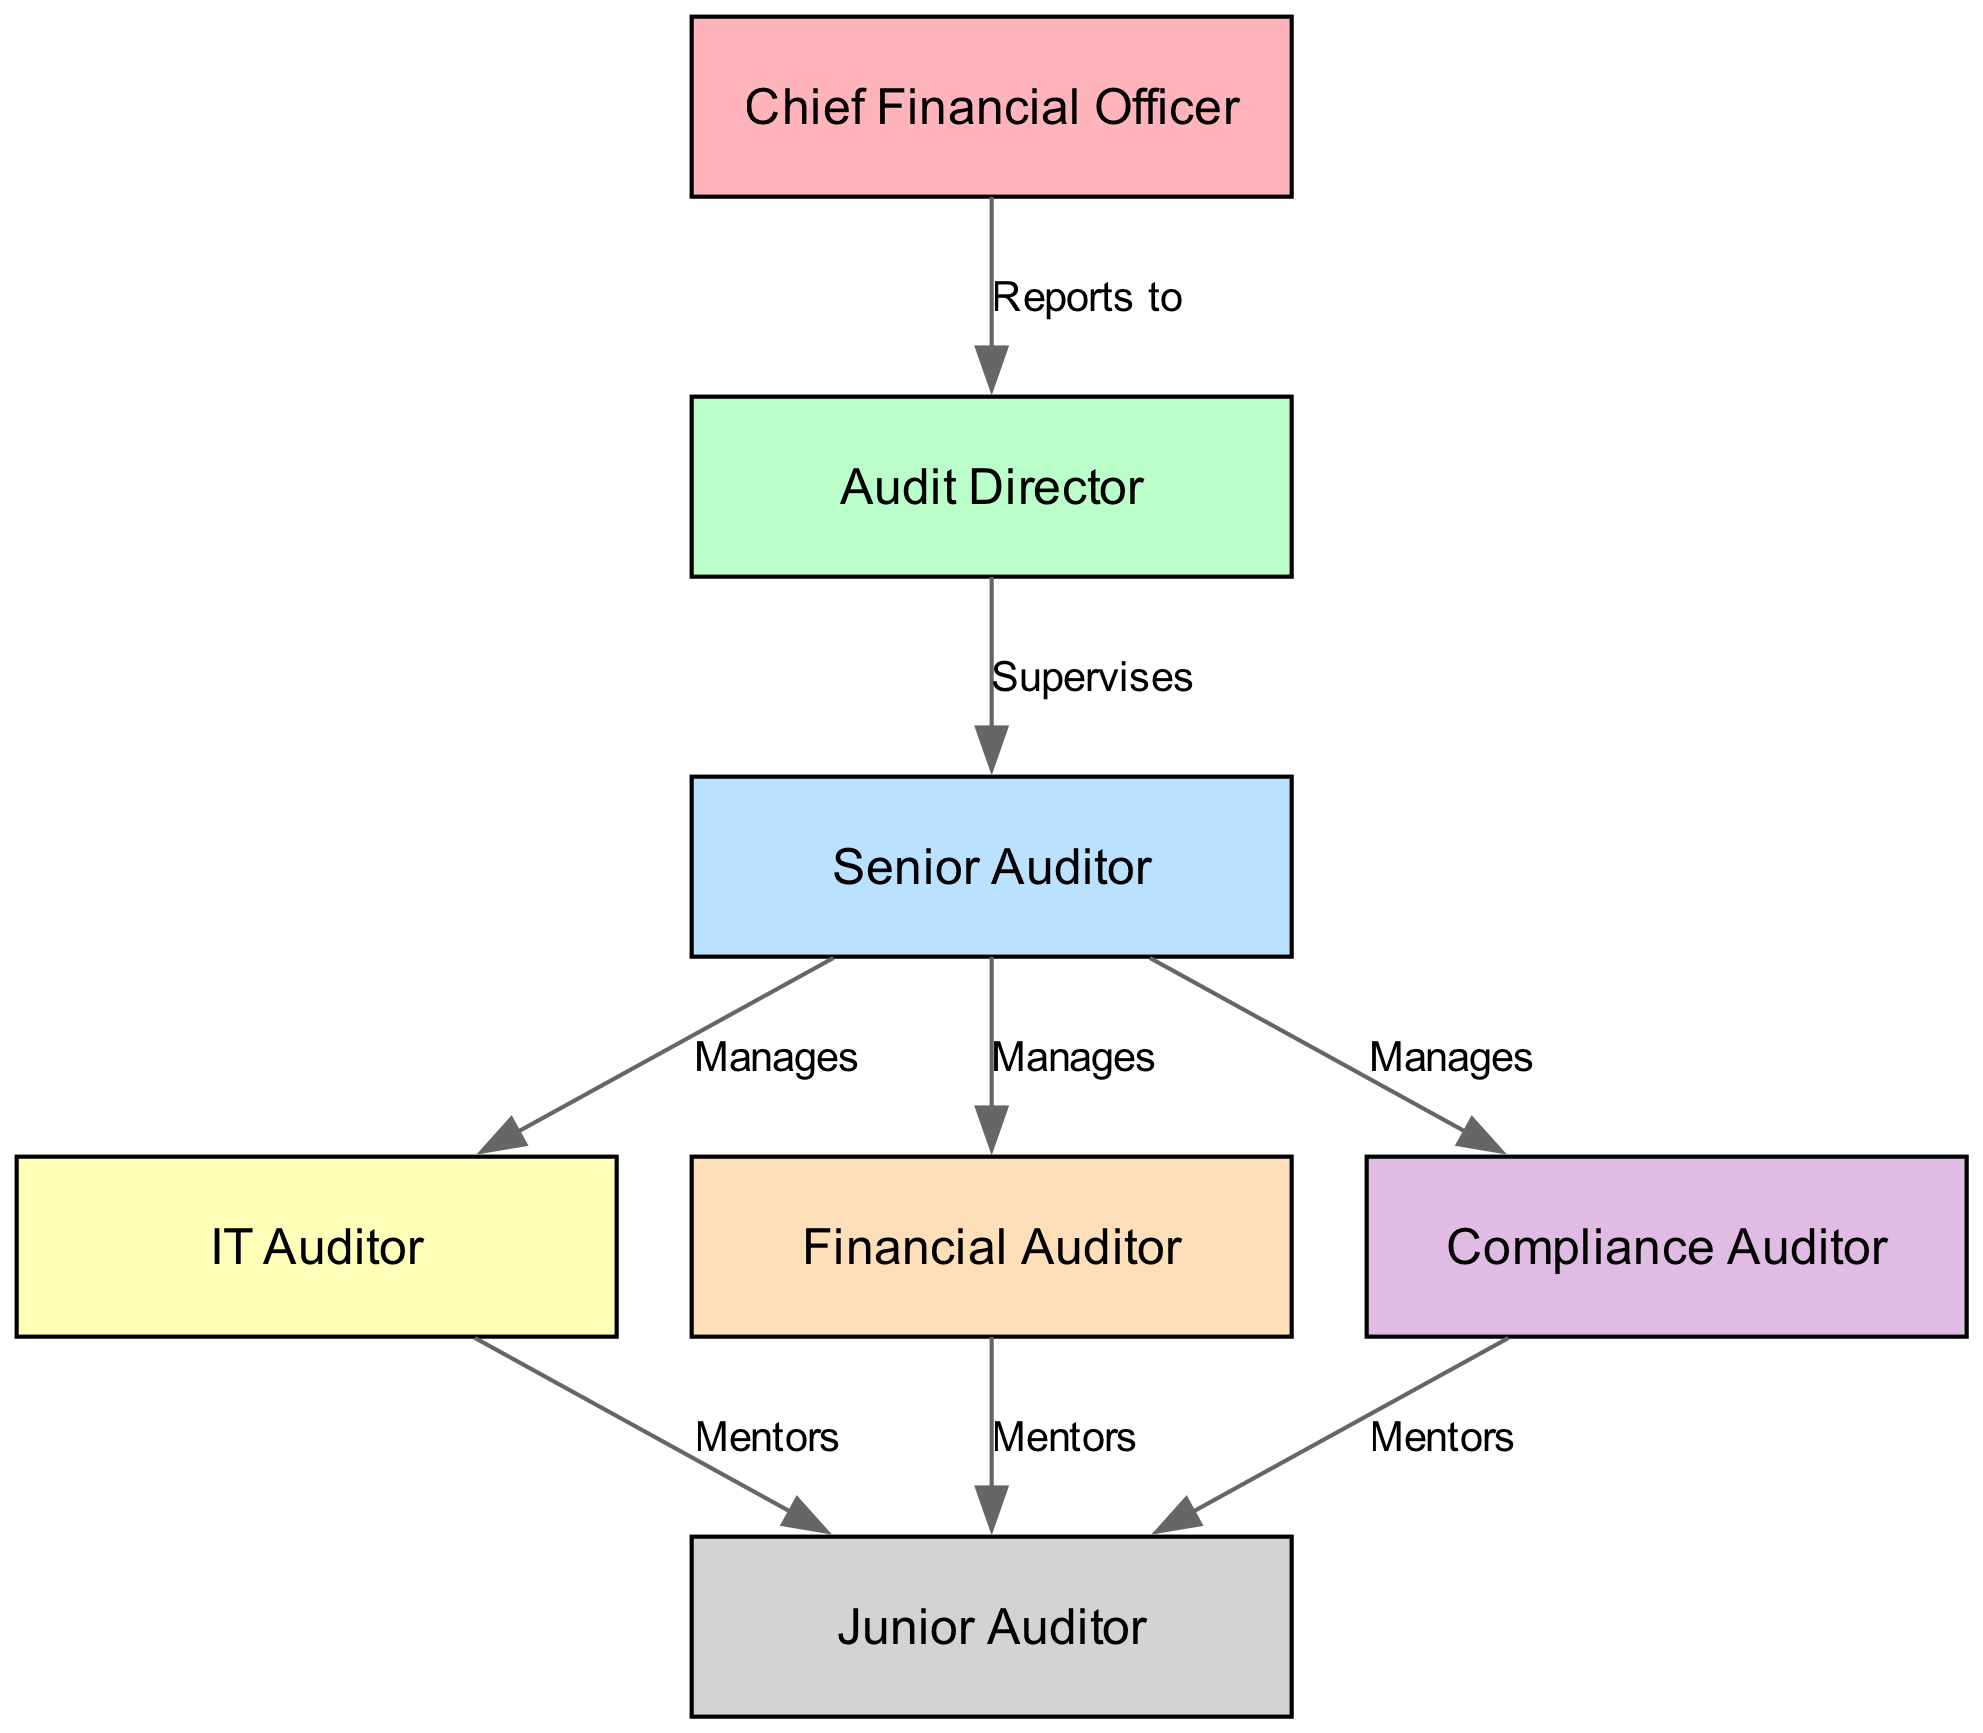What is the highest position in the audit team? The diagram shows the Chief Financial Officer at the top of the organizational structure, which indicates that this role holds the highest position in the audit team.
Answer: Chief Financial Officer How many auditors report to the Audit Director? The diagram clearly shows that one role, the Senior Auditor, is under the Audit Director, indicating that there is only one auditor directly reporting to this position.
Answer: One Who does the Senior Auditor manage? According to the diagram, the Senior Auditor manages three roles: IT Auditor, Financial Auditor, and Compliance Auditor. This indicates the direct oversight the Senior Auditor has over these positions.
Answer: IT Auditor, Financial Auditor, Compliance Auditor Which position directly reports to the Chief Financial Officer? The diagram establishes a direct reporting line from the Chief Financial Officer to the Audit Director, indicating that this is the sole position reporting directly to the CFO.
Answer: Audit Director What role does the IT Auditor mentor? The diagram specifies that the IT Auditor mentors the Junior Auditor, demonstrating a guiding relationship between these two positions.
Answer: Junior Auditor How many total roles are in the audit team? By counting each distinct node in the diagram representing individuals, we total seven roles: Chief Financial Officer, Audit Director, Senior Auditor, IT Auditor, Financial Auditor, Compliance Auditor, and Junior Auditor.
Answer: Seven What are the mentoring roles for the Junior Auditor? The diagram shows that the Junior Auditor is mentored by three roles: IT Auditor, Financial Auditor, and Compliance Auditor. This indicates a collaborative mentorship approach within the team.
Answer: IT Auditor, Financial Auditor, Compliance Auditor Which role supervises the Senior Auditor? The diagram illustrates that the Audit Director supervises the Senior Auditor, indicating an oversight relationship between these two roles.
Answer: Audit Director What kind of relationship exists between the Junior Auditor and the other auditors? The diagram indicates that the Junior Auditor has a mentoring relationship with three auditors: IT Auditor, Financial Auditor, and Compliance Auditor, showing a supportive dynamic in the audit team.
Answer: Mentoring relationship 